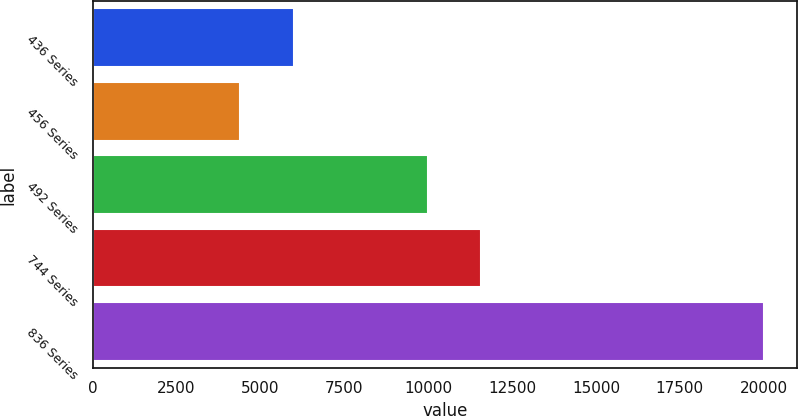<chart> <loc_0><loc_0><loc_500><loc_500><bar_chart><fcel>436 Series<fcel>456 Series<fcel>492 Series<fcel>744 Series<fcel>836 Series<nl><fcel>5992<fcel>4389<fcel>10000<fcel>11561.1<fcel>20000<nl></chart> 